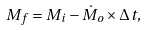<formula> <loc_0><loc_0><loc_500><loc_500>M _ { f } = M _ { i } - \dot { M } _ { o } \times \Delta t ,</formula> 